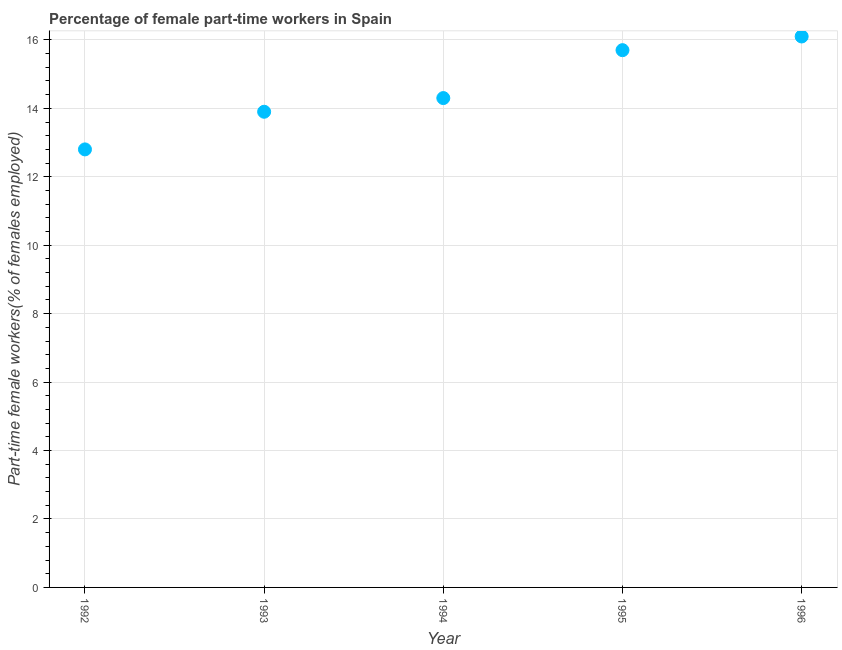What is the percentage of part-time female workers in 1994?
Provide a short and direct response. 14.3. Across all years, what is the maximum percentage of part-time female workers?
Keep it short and to the point. 16.1. Across all years, what is the minimum percentage of part-time female workers?
Keep it short and to the point. 12.8. In which year was the percentage of part-time female workers maximum?
Ensure brevity in your answer.  1996. What is the sum of the percentage of part-time female workers?
Give a very brief answer. 72.8. What is the difference between the percentage of part-time female workers in 1993 and 1996?
Your answer should be very brief. -2.2. What is the average percentage of part-time female workers per year?
Keep it short and to the point. 14.56. What is the median percentage of part-time female workers?
Your response must be concise. 14.3. Do a majority of the years between 1996 and 1994 (inclusive) have percentage of part-time female workers greater than 8.8 %?
Your answer should be very brief. No. What is the ratio of the percentage of part-time female workers in 1992 to that in 1993?
Ensure brevity in your answer.  0.92. Is the percentage of part-time female workers in 1994 less than that in 1995?
Your answer should be compact. Yes. Is the difference between the percentage of part-time female workers in 1992 and 1994 greater than the difference between any two years?
Offer a terse response. No. What is the difference between the highest and the second highest percentage of part-time female workers?
Provide a short and direct response. 0.4. What is the difference between the highest and the lowest percentage of part-time female workers?
Your answer should be very brief. 3.3. In how many years, is the percentage of part-time female workers greater than the average percentage of part-time female workers taken over all years?
Ensure brevity in your answer.  2. How many dotlines are there?
Offer a terse response. 1. What is the difference between two consecutive major ticks on the Y-axis?
Your answer should be compact. 2. Are the values on the major ticks of Y-axis written in scientific E-notation?
Your answer should be compact. No. What is the title of the graph?
Ensure brevity in your answer.  Percentage of female part-time workers in Spain. What is the label or title of the X-axis?
Your answer should be compact. Year. What is the label or title of the Y-axis?
Your response must be concise. Part-time female workers(% of females employed). What is the Part-time female workers(% of females employed) in 1992?
Offer a terse response. 12.8. What is the Part-time female workers(% of females employed) in 1993?
Your response must be concise. 13.9. What is the Part-time female workers(% of females employed) in 1994?
Offer a very short reply. 14.3. What is the Part-time female workers(% of females employed) in 1995?
Give a very brief answer. 15.7. What is the Part-time female workers(% of females employed) in 1996?
Ensure brevity in your answer.  16.1. What is the difference between the Part-time female workers(% of females employed) in 1992 and 1994?
Offer a very short reply. -1.5. What is the difference between the Part-time female workers(% of females employed) in 1992 and 1995?
Give a very brief answer. -2.9. What is the difference between the Part-time female workers(% of females employed) in 1993 and 1994?
Offer a very short reply. -0.4. What is the difference between the Part-time female workers(% of females employed) in 1993 and 1995?
Your answer should be compact. -1.8. What is the difference between the Part-time female workers(% of females employed) in 1994 and 1995?
Offer a terse response. -1.4. What is the ratio of the Part-time female workers(% of females employed) in 1992 to that in 1993?
Your answer should be very brief. 0.92. What is the ratio of the Part-time female workers(% of females employed) in 1992 to that in 1994?
Ensure brevity in your answer.  0.9. What is the ratio of the Part-time female workers(% of females employed) in 1992 to that in 1995?
Your answer should be very brief. 0.81. What is the ratio of the Part-time female workers(% of females employed) in 1992 to that in 1996?
Your answer should be compact. 0.8. What is the ratio of the Part-time female workers(% of females employed) in 1993 to that in 1994?
Give a very brief answer. 0.97. What is the ratio of the Part-time female workers(% of females employed) in 1993 to that in 1995?
Offer a very short reply. 0.89. What is the ratio of the Part-time female workers(% of females employed) in 1993 to that in 1996?
Give a very brief answer. 0.86. What is the ratio of the Part-time female workers(% of females employed) in 1994 to that in 1995?
Offer a terse response. 0.91. What is the ratio of the Part-time female workers(% of females employed) in 1994 to that in 1996?
Your answer should be very brief. 0.89. What is the ratio of the Part-time female workers(% of females employed) in 1995 to that in 1996?
Provide a succinct answer. 0.97. 